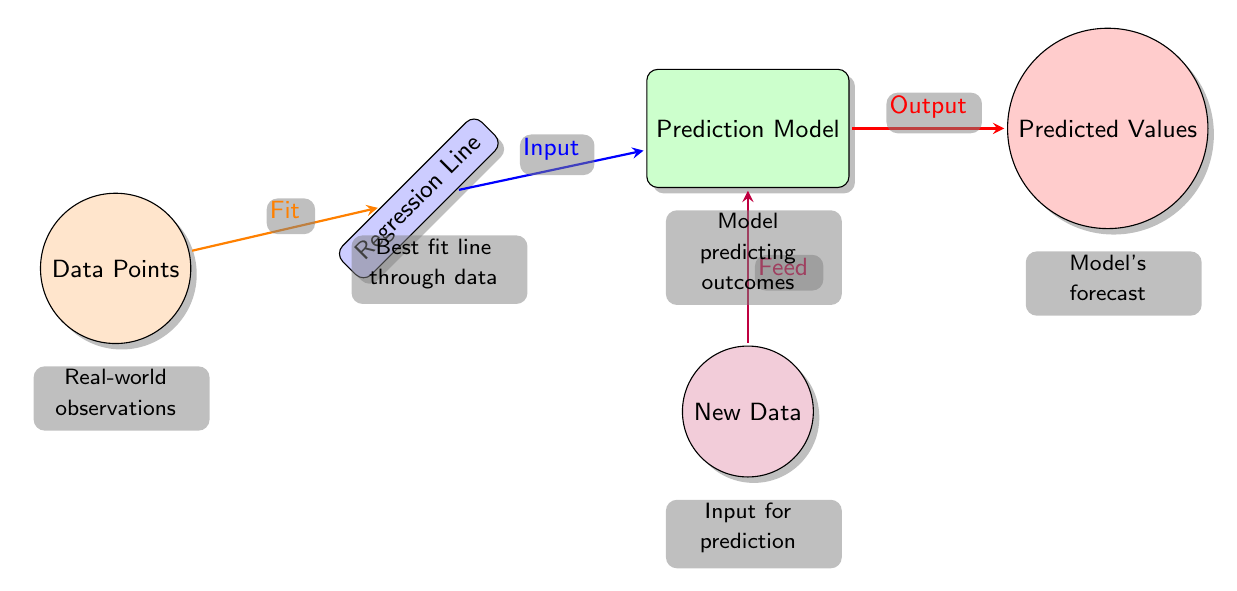What are the colors used for the nodes in the diagram? The diagram consists of five nodes, each represented in different colors: orange, blue, green, purple, and red.
Answer: orange, blue, green, purple, red What does the "Regression Line" node represent? The "Regression Line" node shows the best fit line through the data, illustrating how the model attempts to summarize the relationship between variables.
Answer: Best fit line through data How many edges connect the "Data Points" node to the "Regression Line" node? There is a single arrow labeled "Fit" that connects the "Data Points" node to the "Regression Line" node, indicating a direct relationship.
Answer: 1 What element does the "New Data" node contribute to in the diagram? The "New Data" node provides input that is fed into the "Prediction Model," which uses the data to make forecasts.
Answer: Feed What information flows from the "Prediction Model" node to the "Predicted Values" node? The "Prediction Model" outputs predicted values based on the data input and the learned relationship from the regression analysis, which is conveyed as an arrow labeled "Output."
Answer: Output What is the connection type between "Regression Line" and "Prediction Model"? The connection is characterized by the arrow labeled "Input," signifying that the regression line serves as an input feature for the prediction model.
Answer: Input How does the "Data Points" relate to the "Predicted Values"? The "Data Points" indirectly influence the "Predicted Values" through the processing of the regression line and prediction model, representing a multi-step flow from observation to forecast.
Answer: Multi-step flow What function does the "Prediction Model" node serve? The "Prediction Model" node functions to predict outcomes based on the processed inputs it receives from both the regression line and new data.
Answer: Model predicting outcomes 